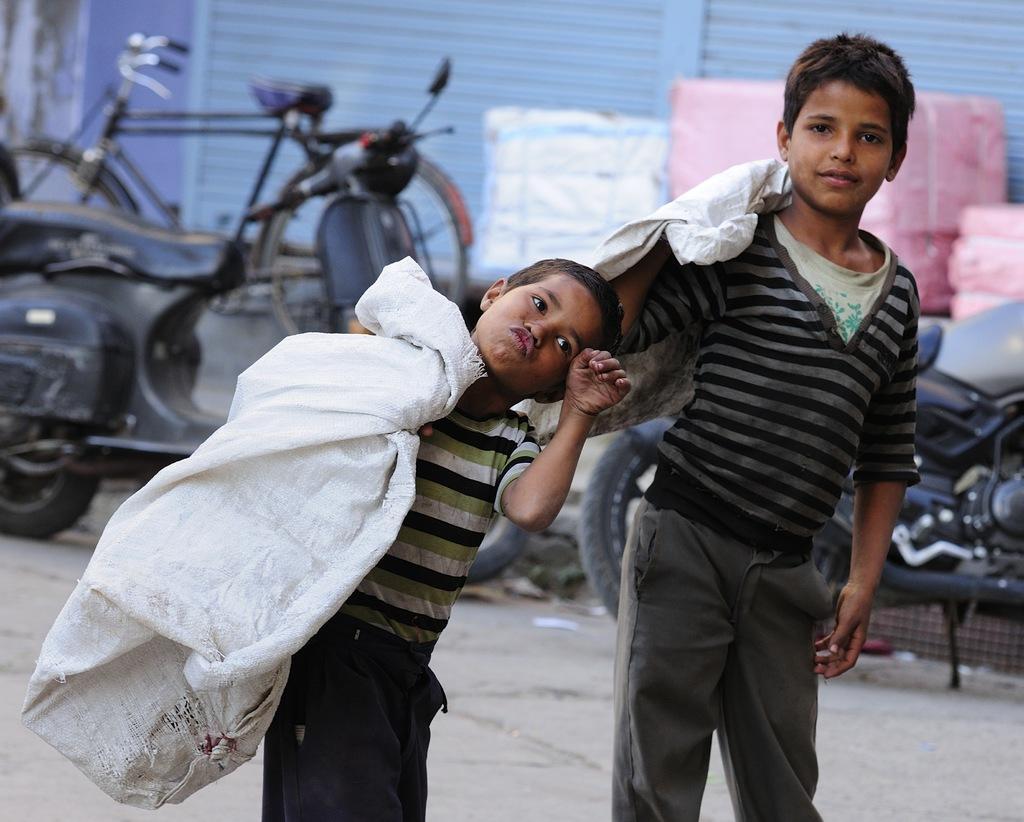How would you summarize this image in a sentence or two? In this image I can see two people with different color dresses and these people are holding the bags. In the background I can see the motorbikes, bicycle and few more objects. I can see the blue color rolling shutter in the back. 